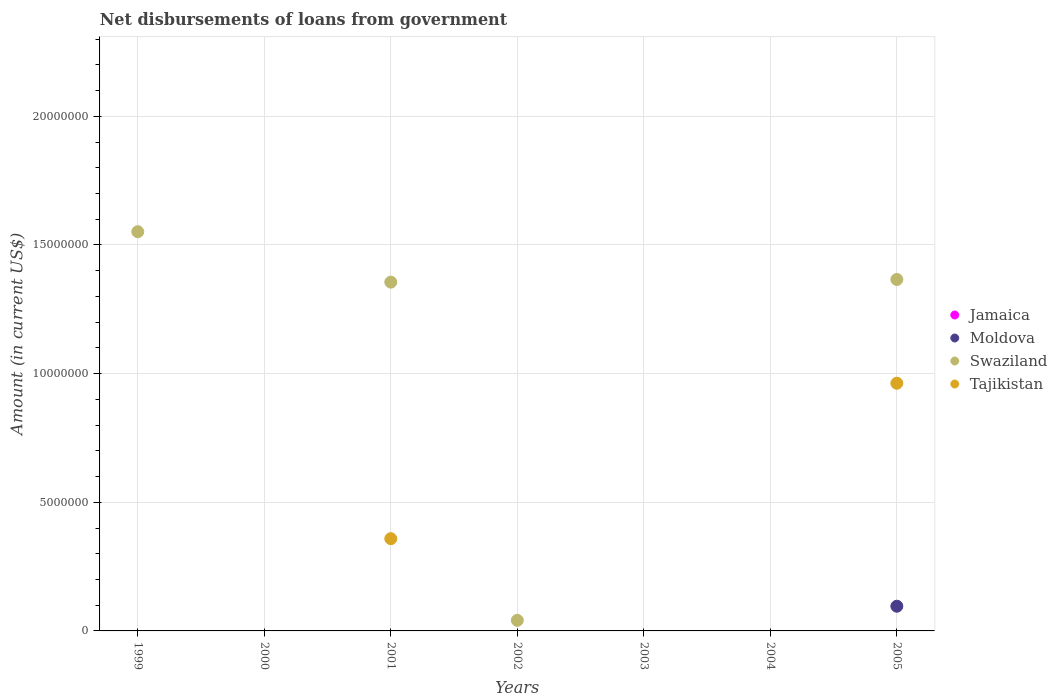How many different coloured dotlines are there?
Ensure brevity in your answer.  3. Is the number of dotlines equal to the number of legend labels?
Ensure brevity in your answer.  No. What is the amount of loan disbursed from government in Jamaica in 2003?
Make the answer very short. 0. Across all years, what is the maximum amount of loan disbursed from government in Tajikistan?
Your answer should be very brief. 9.63e+06. Across all years, what is the minimum amount of loan disbursed from government in Jamaica?
Offer a terse response. 0. In which year was the amount of loan disbursed from government in Tajikistan maximum?
Offer a terse response. 2005. What is the difference between the amount of loan disbursed from government in Swaziland in 2001 and that in 2005?
Your response must be concise. -1.04e+05. In the year 2001, what is the difference between the amount of loan disbursed from government in Tajikistan and amount of loan disbursed from government in Swaziland?
Your response must be concise. -9.97e+06. In how many years, is the amount of loan disbursed from government in Tajikistan greater than 1000000 US$?
Your response must be concise. 2. What is the ratio of the amount of loan disbursed from government in Swaziland in 1999 to that in 2001?
Your answer should be very brief. 1.14. What is the difference between the highest and the second highest amount of loan disbursed from government in Swaziland?
Offer a very short reply. 1.86e+06. What is the difference between the highest and the lowest amount of loan disbursed from government in Moldova?
Provide a succinct answer. 9.60e+05. In how many years, is the amount of loan disbursed from government in Swaziland greater than the average amount of loan disbursed from government in Swaziland taken over all years?
Your answer should be very brief. 3. Is it the case that in every year, the sum of the amount of loan disbursed from government in Moldova and amount of loan disbursed from government in Jamaica  is greater than the amount of loan disbursed from government in Tajikistan?
Your response must be concise. No. Is the amount of loan disbursed from government in Moldova strictly greater than the amount of loan disbursed from government in Jamaica over the years?
Your answer should be compact. Yes. How are the legend labels stacked?
Ensure brevity in your answer.  Vertical. What is the title of the graph?
Your answer should be compact. Net disbursements of loans from government. Does "Niger" appear as one of the legend labels in the graph?
Your answer should be compact. No. What is the Amount (in current US$) in Swaziland in 1999?
Make the answer very short. 1.55e+07. What is the Amount (in current US$) of Tajikistan in 1999?
Provide a succinct answer. 0. What is the Amount (in current US$) in Jamaica in 2000?
Your response must be concise. 0. What is the Amount (in current US$) of Jamaica in 2001?
Offer a terse response. 0. What is the Amount (in current US$) in Swaziland in 2001?
Give a very brief answer. 1.36e+07. What is the Amount (in current US$) of Tajikistan in 2001?
Offer a terse response. 3.58e+06. What is the Amount (in current US$) of Jamaica in 2002?
Your answer should be very brief. 0. What is the Amount (in current US$) in Moldova in 2002?
Give a very brief answer. 0. What is the Amount (in current US$) of Swaziland in 2002?
Keep it short and to the point. 4.11e+05. What is the Amount (in current US$) in Tajikistan in 2002?
Give a very brief answer. 0. What is the Amount (in current US$) of Moldova in 2004?
Provide a short and direct response. 0. What is the Amount (in current US$) in Swaziland in 2004?
Make the answer very short. 0. What is the Amount (in current US$) of Jamaica in 2005?
Make the answer very short. 0. What is the Amount (in current US$) of Moldova in 2005?
Keep it short and to the point. 9.60e+05. What is the Amount (in current US$) of Swaziland in 2005?
Keep it short and to the point. 1.37e+07. What is the Amount (in current US$) of Tajikistan in 2005?
Offer a very short reply. 9.63e+06. Across all years, what is the maximum Amount (in current US$) of Moldova?
Offer a very short reply. 9.60e+05. Across all years, what is the maximum Amount (in current US$) in Swaziland?
Your answer should be very brief. 1.55e+07. Across all years, what is the maximum Amount (in current US$) in Tajikistan?
Your answer should be very brief. 9.63e+06. Across all years, what is the minimum Amount (in current US$) of Moldova?
Provide a short and direct response. 0. What is the total Amount (in current US$) in Jamaica in the graph?
Your response must be concise. 0. What is the total Amount (in current US$) of Moldova in the graph?
Your answer should be very brief. 9.60e+05. What is the total Amount (in current US$) in Swaziland in the graph?
Give a very brief answer. 4.31e+07. What is the total Amount (in current US$) of Tajikistan in the graph?
Give a very brief answer. 1.32e+07. What is the difference between the Amount (in current US$) of Swaziland in 1999 and that in 2001?
Offer a very short reply. 1.96e+06. What is the difference between the Amount (in current US$) of Swaziland in 1999 and that in 2002?
Provide a short and direct response. 1.51e+07. What is the difference between the Amount (in current US$) in Swaziland in 1999 and that in 2005?
Your response must be concise. 1.86e+06. What is the difference between the Amount (in current US$) in Swaziland in 2001 and that in 2002?
Your answer should be very brief. 1.31e+07. What is the difference between the Amount (in current US$) of Swaziland in 2001 and that in 2005?
Your answer should be very brief. -1.04e+05. What is the difference between the Amount (in current US$) in Tajikistan in 2001 and that in 2005?
Offer a very short reply. -6.04e+06. What is the difference between the Amount (in current US$) in Swaziland in 2002 and that in 2005?
Give a very brief answer. -1.32e+07. What is the difference between the Amount (in current US$) of Swaziland in 1999 and the Amount (in current US$) of Tajikistan in 2001?
Provide a short and direct response. 1.19e+07. What is the difference between the Amount (in current US$) of Swaziland in 1999 and the Amount (in current US$) of Tajikistan in 2005?
Offer a terse response. 5.89e+06. What is the difference between the Amount (in current US$) of Swaziland in 2001 and the Amount (in current US$) of Tajikistan in 2005?
Your answer should be compact. 3.93e+06. What is the difference between the Amount (in current US$) of Swaziland in 2002 and the Amount (in current US$) of Tajikistan in 2005?
Keep it short and to the point. -9.22e+06. What is the average Amount (in current US$) of Jamaica per year?
Offer a very short reply. 0. What is the average Amount (in current US$) in Moldova per year?
Keep it short and to the point. 1.37e+05. What is the average Amount (in current US$) of Swaziland per year?
Give a very brief answer. 6.16e+06. What is the average Amount (in current US$) in Tajikistan per year?
Your answer should be very brief. 1.89e+06. In the year 2001, what is the difference between the Amount (in current US$) of Swaziland and Amount (in current US$) of Tajikistan?
Make the answer very short. 9.97e+06. In the year 2005, what is the difference between the Amount (in current US$) in Moldova and Amount (in current US$) in Swaziland?
Ensure brevity in your answer.  -1.27e+07. In the year 2005, what is the difference between the Amount (in current US$) of Moldova and Amount (in current US$) of Tajikistan?
Your answer should be compact. -8.67e+06. In the year 2005, what is the difference between the Amount (in current US$) in Swaziland and Amount (in current US$) in Tajikistan?
Give a very brief answer. 4.03e+06. What is the ratio of the Amount (in current US$) in Swaziland in 1999 to that in 2001?
Provide a succinct answer. 1.14. What is the ratio of the Amount (in current US$) in Swaziland in 1999 to that in 2002?
Make the answer very short. 37.75. What is the ratio of the Amount (in current US$) of Swaziland in 1999 to that in 2005?
Your answer should be compact. 1.14. What is the ratio of the Amount (in current US$) of Swaziland in 2001 to that in 2002?
Provide a succinct answer. 32.98. What is the ratio of the Amount (in current US$) of Tajikistan in 2001 to that in 2005?
Give a very brief answer. 0.37. What is the ratio of the Amount (in current US$) in Swaziland in 2002 to that in 2005?
Your response must be concise. 0.03. What is the difference between the highest and the second highest Amount (in current US$) of Swaziland?
Your answer should be very brief. 1.86e+06. What is the difference between the highest and the lowest Amount (in current US$) in Moldova?
Your response must be concise. 9.60e+05. What is the difference between the highest and the lowest Amount (in current US$) in Swaziland?
Provide a short and direct response. 1.55e+07. What is the difference between the highest and the lowest Amount (in current US$) in Tajikistan?
Provide a short and direct response. 9.63e+06. 